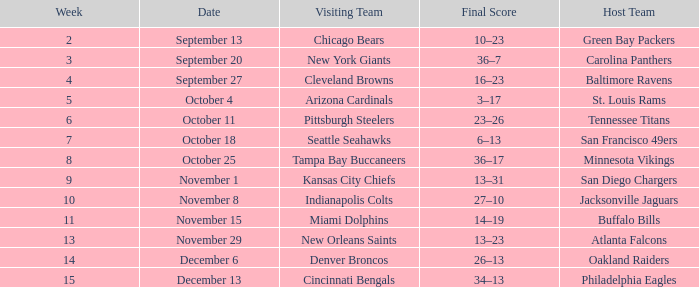When did the Baltimore Ravens play at home ? September 27. 